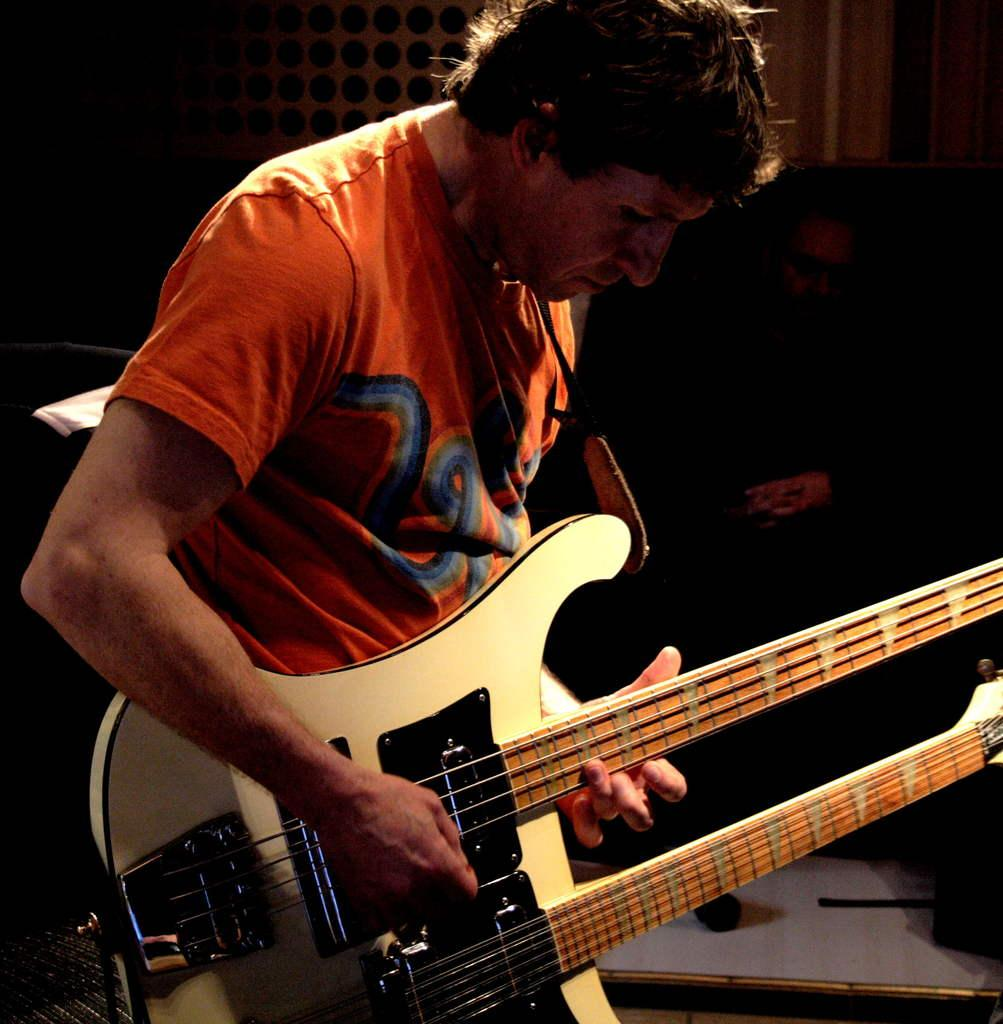What is present in the image? There is a man in the image. What is the man doing in the image? The man is standing in the image. What object is the man holding in the image? The man is holding a guitar in the image. What type of stove can be seen in the image? There is no stove present in the image. What riddle is the man trying to solve in the image? There is no riddle present in the image. 